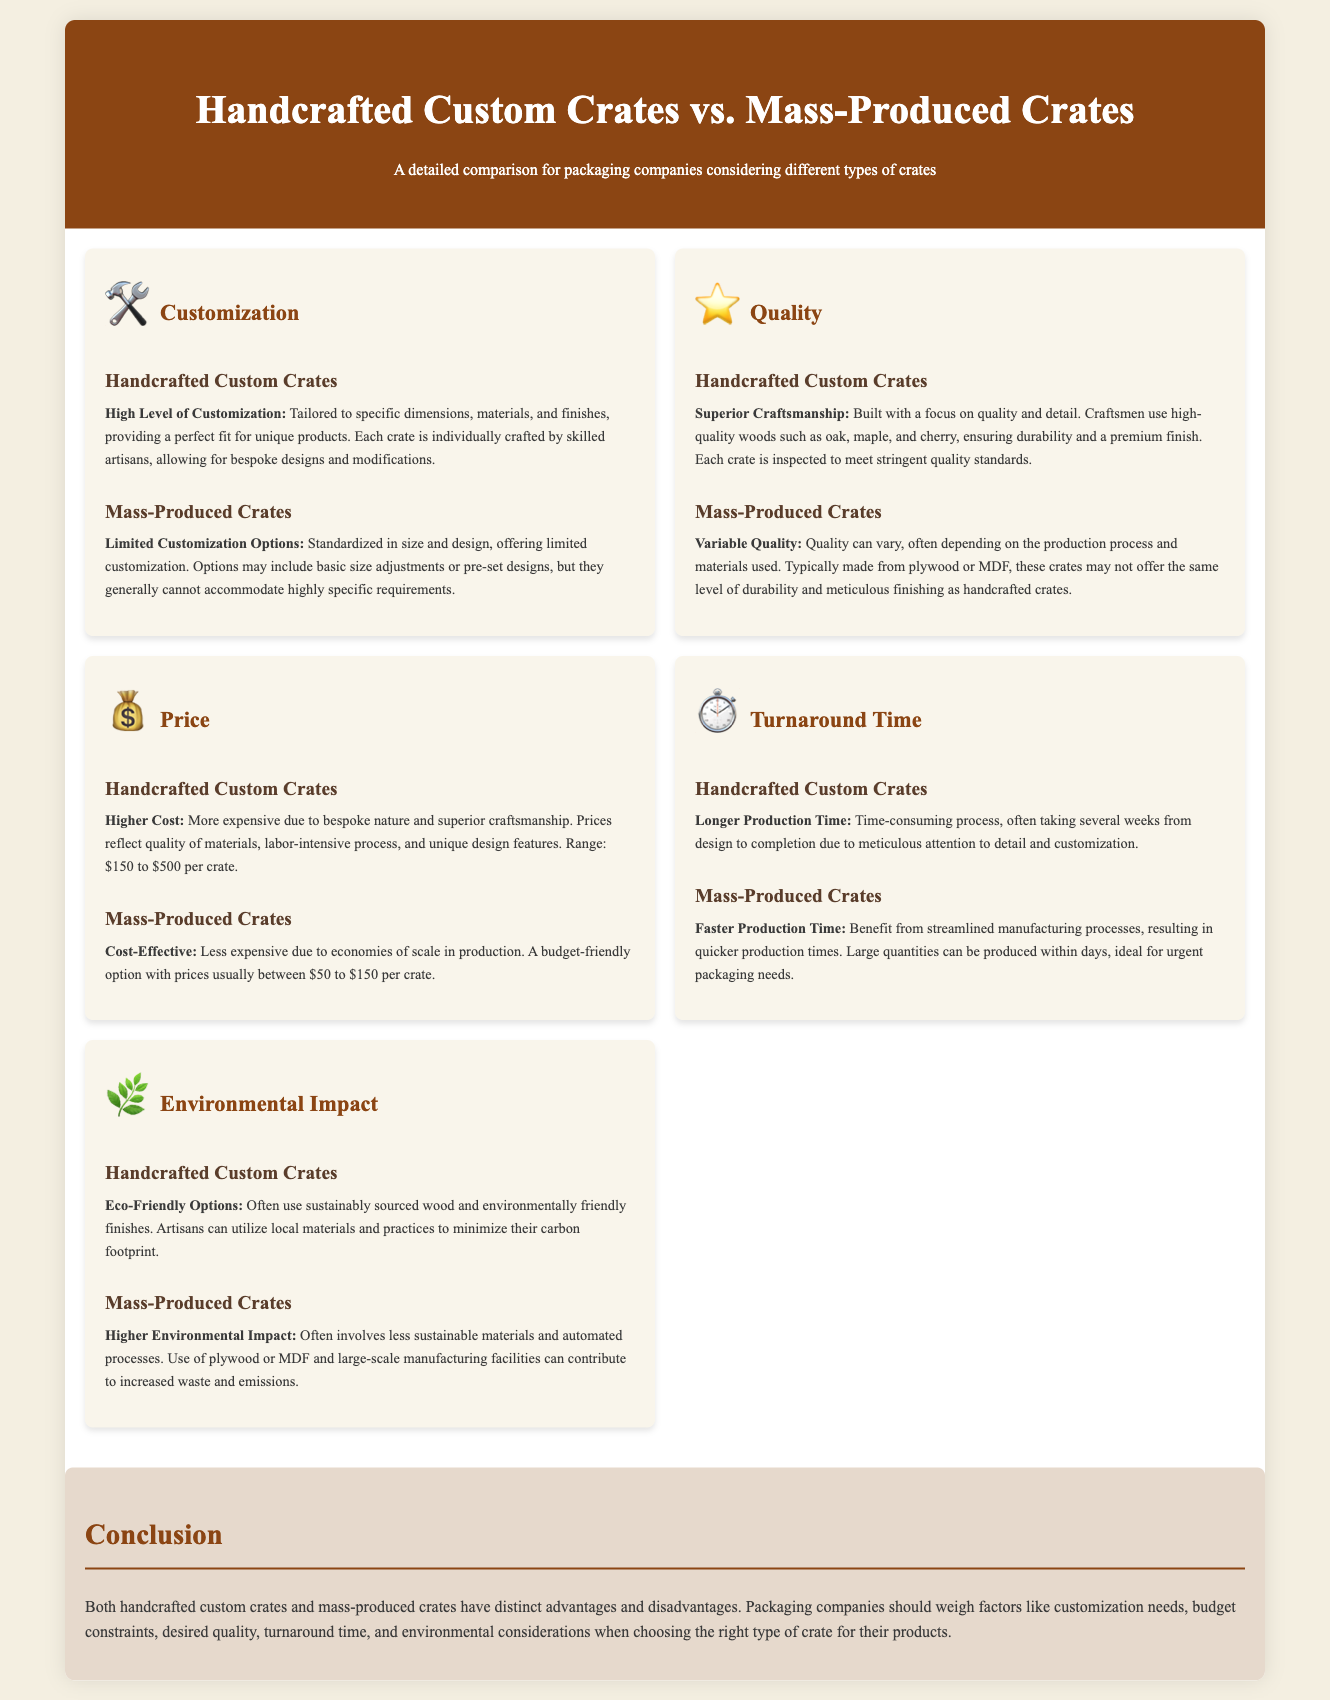What is the range of prices for handcrafted custom crates? The price range for handcrafted custom crates is specified in the document.
Answer: $150 to $500 What material is commonly used for mass-produced crates? The document states that mass-produced crates are typically made from certain materials.
Answer: Plywood or MDF Which type of crates offers a higher level of customization? The comparison in the document highlights the customization capabilities of each crate type.
Answer: Handcrafted Custom Crates What is the turnaround time for mass-produced crates? The document provides information about the production timing for mass-produced crates.
Answer: Faster Production Time Which crate type is described as having superior craftsmanship? The document makes a clear distinction regarding the quality of craftsmanship in relation to the crate types.
Answer: Handcrafted Custom Crates What is one environmental consideration for handcrafted custom crates? The document references environmental practices associated with handcrafted crates.
Answer: Eco-Friendly Options How does the production process of handcrafted custom crates compare in terms of time? The document outlines the production time fact for each type of crate.
Answer: Longer Production Time What is the customization option level of mass-produced crates? The document provides specific details on the level of customization for mass-produced crates.
Answer: Limited Customization Options 